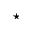Convert formula to latex. <formula><loc_0><loc_0><loc_500><loc_500>^ { * }</formula> 